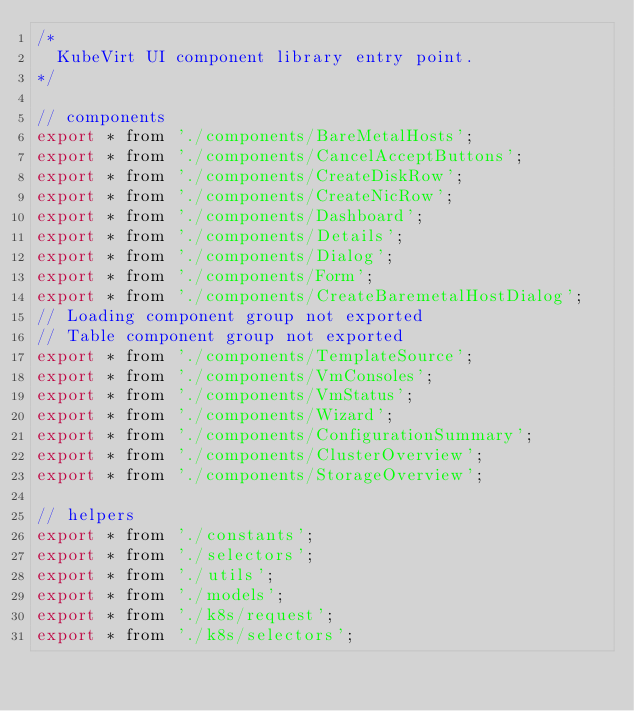<code> <loc_0><loc_0><loc_500><loc_500><_JavaScript_>/*
  KubeVirt UI component library entry point.
*/

// components
export * from './components/BareMetalHosts';
export * from './components/CancelAcceptButtons';
export * from './components/CreateDiskRow';
export * from './components/CreateNicRow';
export * from './components/Dashboard';
export * from './components/Details';
export * from './components/Dialog';
export * from './components/Form';
export * from './components/CreateBaremetalHostDialog';
// Loading component group not exported
// Table component group not exported
export * from './components/TemplateSource';
export * from './components/VmConsoles';
export * from './components/VmStatus';
export * from './components/Wizard';
export * from './components/ConfigurationSummary';
export * from './components/ClusterOverview';
export * from './components/StorageOverview';

// helpers
export * from './constants';
export * from './selectors';
export * from './utils';
export * from './models';
export * from './k8s/request';
export * from './k8s/selectors';
</code> 